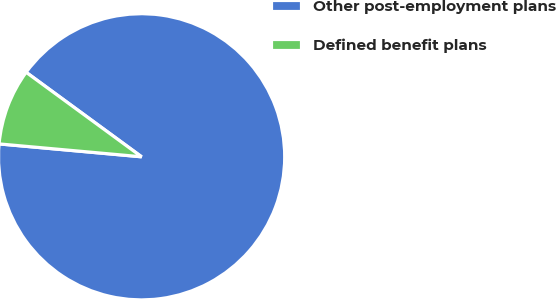Convert chart. <chart><loc_0><loc_0><loc_500><loc_500><pie_chart><fcel>Other post-employment plans<fcel>Defined benefit plans<nl><fcel>91.38%<fcel>8.62%<nl></chart> 